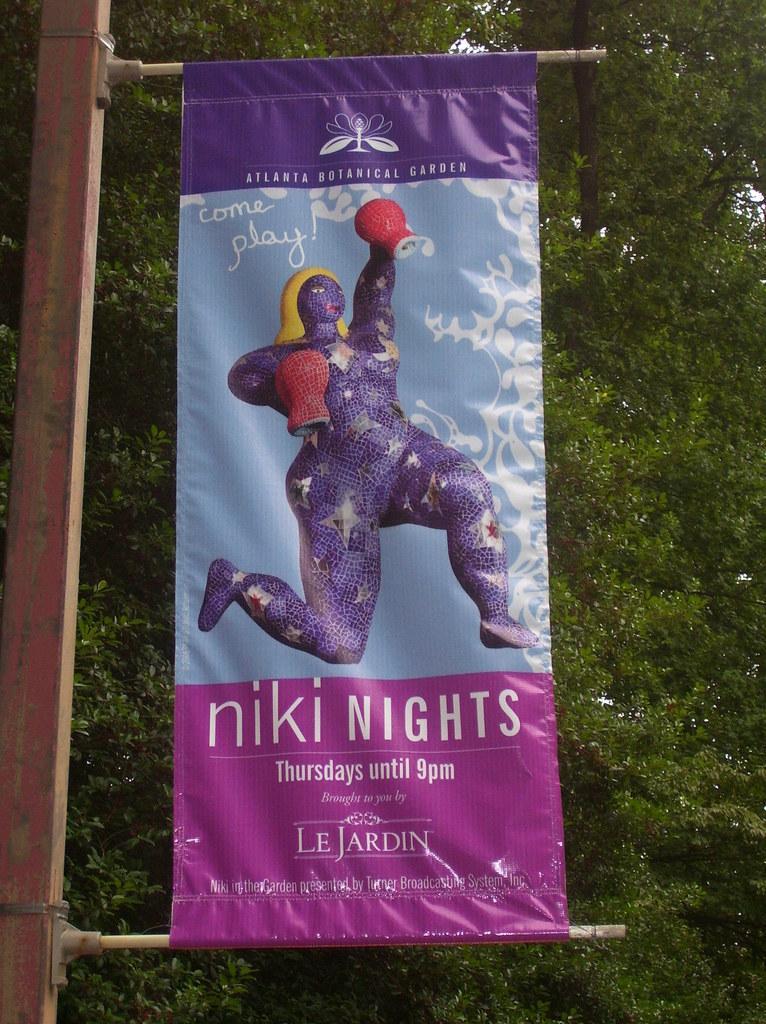Can you describe this image briefly? In this picture we can see a banner attached to a pole. In the background of the image we can see leaves. 